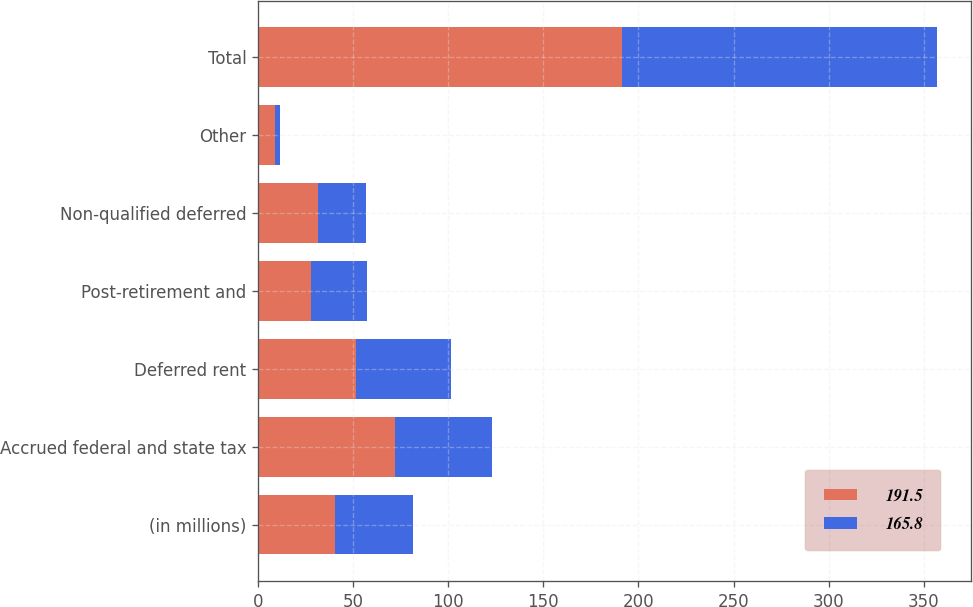Convert chart to OTSL. <chart><loc_0><loc_0><loc_500><loc_500><stacked_bar_chart><ecel><fcel>(in millions)<fcel>Accrued federal and state tax<fcel>Deferred rent<fcel>Post-retirement and<fcel>Non-qualified deferred<fcel>Other<fcel>Total<nl><fcel>191.5<fcel>40.6<fcel>71.9<fcel>51.6<fcel>27.7<fcel>31.3<fcel>9<fcel>191.5<nl><fcel>165.8<fcel>40.6<fcel>51.3<fcel>49.9<fcel>29.5<fcel>25.6<fcel>2.5<fcel>165.8<nl></chart> 